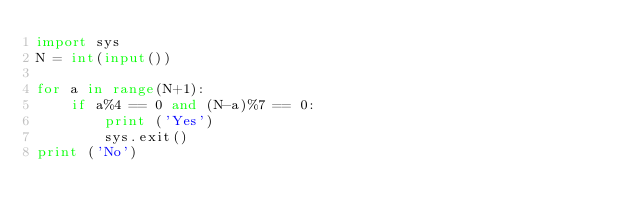Convert code to text. <code><loc_0><loc_0><loc_500><loc_500><_Python_>import sys
N = int(input())

for a in range(N+1):
    if a%4 == 0 and (N-a)%7 == 0:
        print ('Yes')
        sys.exit()
print ('No')</code> 